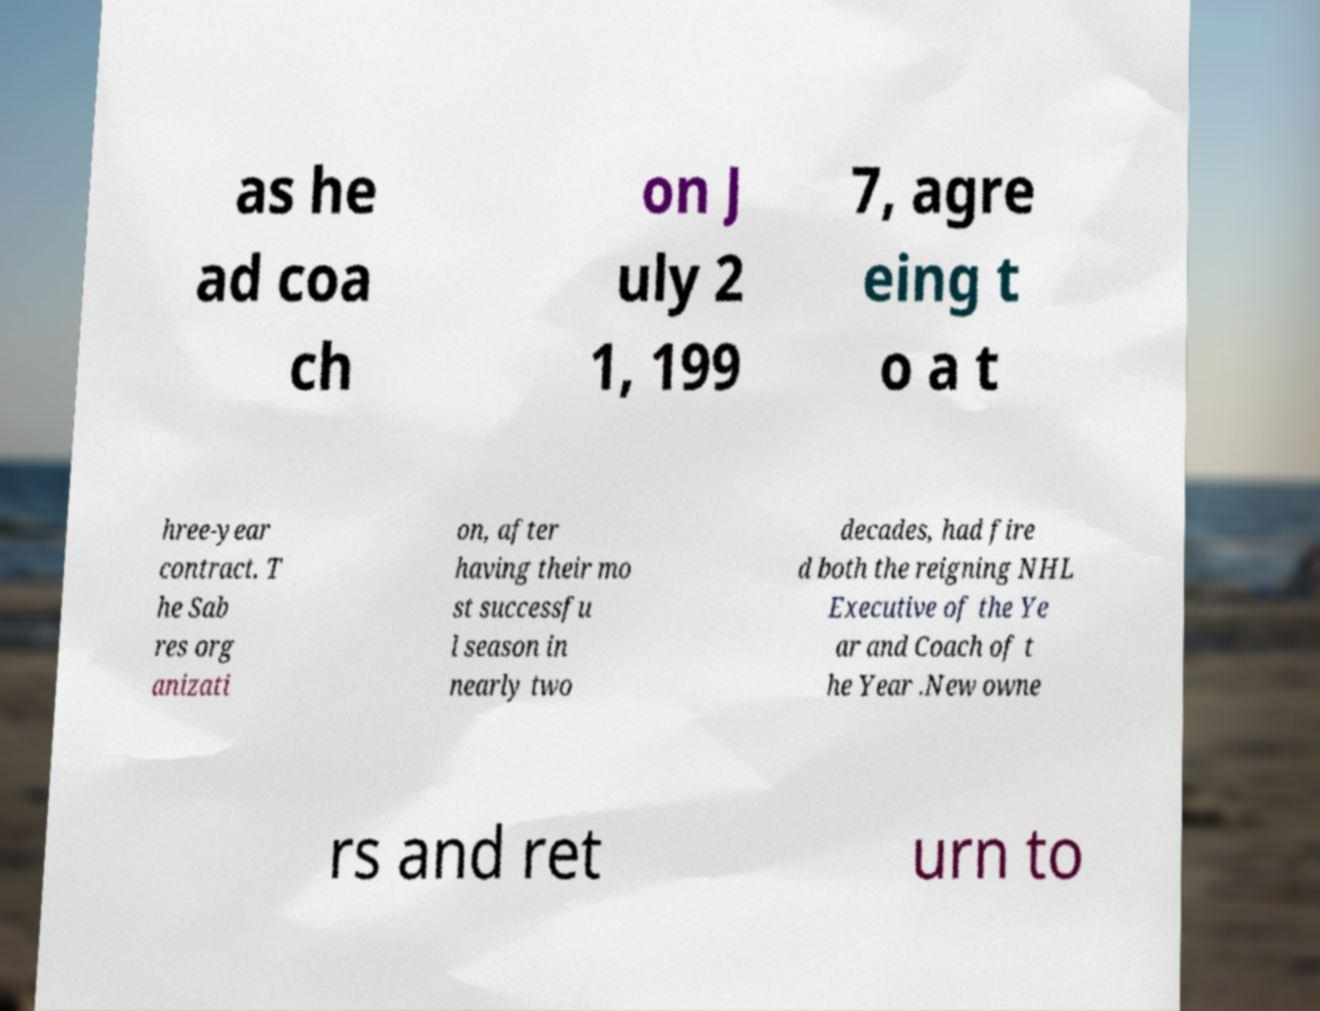Please identify and transcribe the text found in this image. as he ad coa ch on J uly 2 1, 199 7, agre eing t o a t hree-year contract. T he Sab res org anizati on, after having their mo st successfu l season in nearly two decades, had fire d both the reigning NHL Executive of the Ye ar and Coach of t he Year .New owne rs and ret urn to 